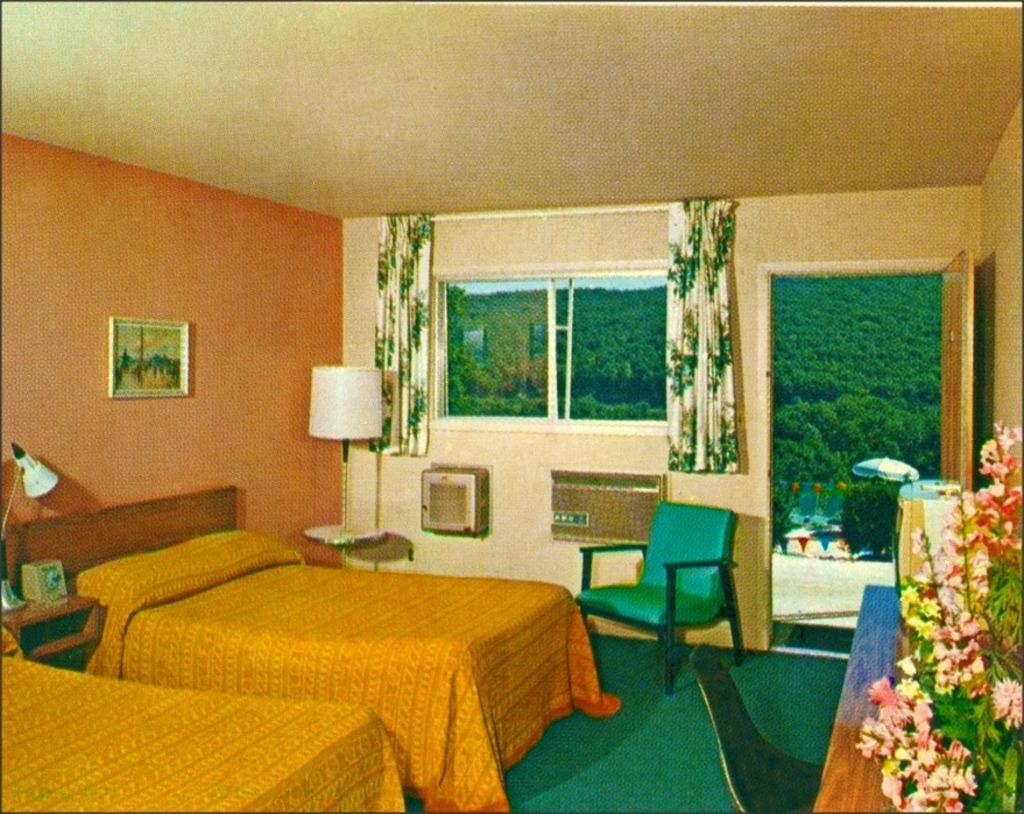How would you summarize this image in a sentence or two? The picture is clicked inside a room. In the room there are two beds with yellow bed cover. Here on a table there is a lamp. On the wall there is a painting. Here there is a lamp. In the right on a table there is bouquet and books. Here there is a chair. Another chair here. This is glass window. These are curtains. This is a door. Outside there are tree, and buildings. 